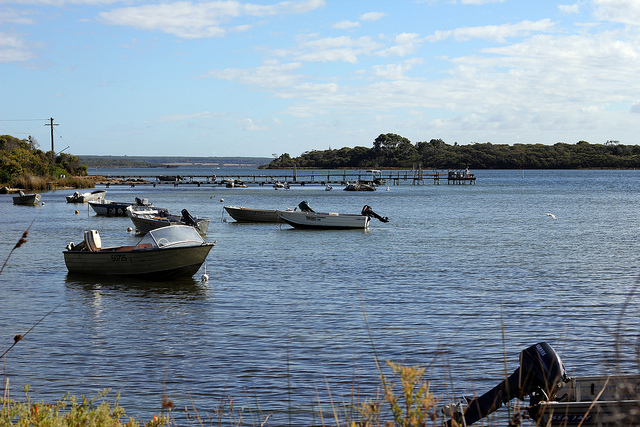What would be a brief moment of excitement in this peaceful setting? A brief moment of excitement might occur as one of the boats spots an unexpected flash of movement in the water—a large fish breaking the surface or perhaps a playful otter making its way across the lake. The sudden activity would ripple through the stillness, drawing the attention of everyone on the water and creating a flurry of excitement and chatter, adding a delightful dash of spontaneity to the tranquil day. 